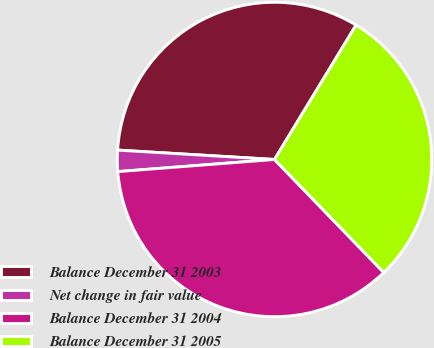Convert chart. <chart><loc_0><loc_0><loc_500><loc_500><pie_chart><fcel>Balance December 31 2003<fcel>Net change in fair value<fcel>Balance December 31 2004<fcel>Balance December 31 2005<nl><fcel>32.73%<fcel>2.18%<fcel>36.0%<fcel>29.09%<nl></chart> 